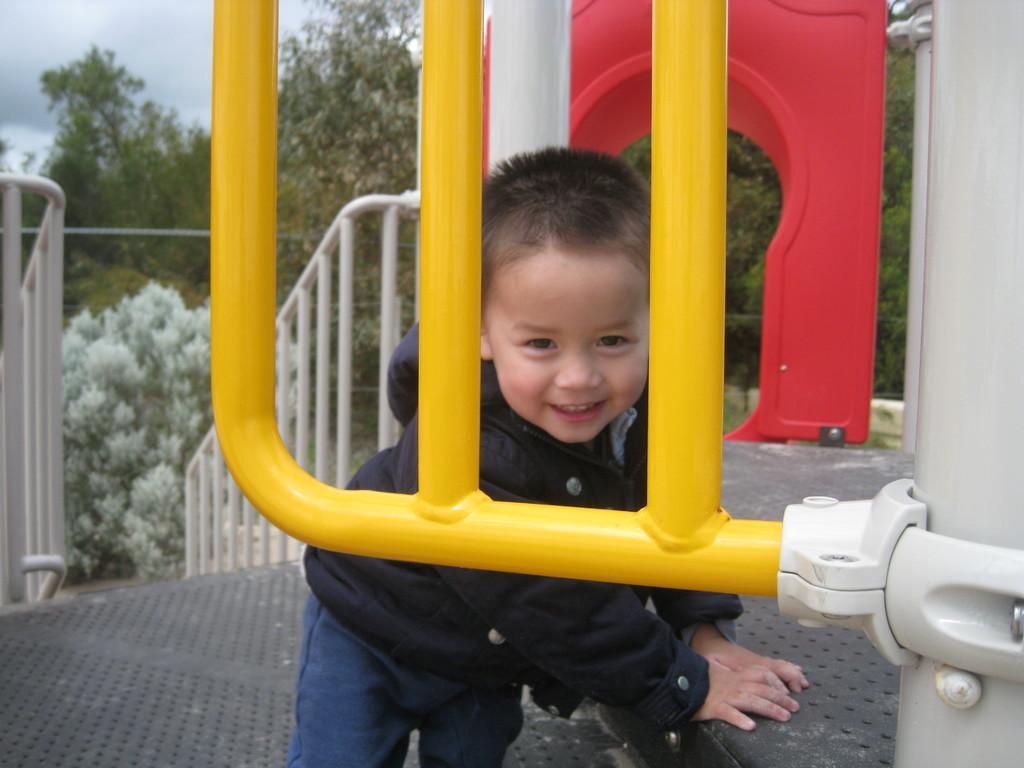In one or two sentences, can you explain what this image depicts? In this image we can see a kid, there are handrails, there is a red colored objects, there are trees, also we can see the sky. 